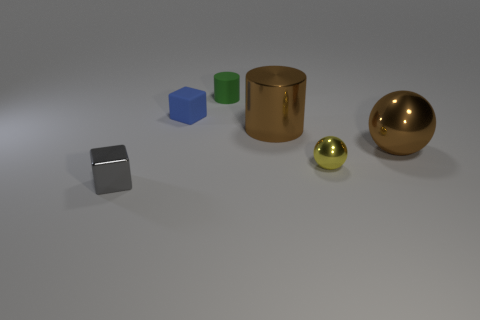Are there any patterns or textures visible on the surfaces in the image? The objects in the image display smooth surfaces without any distinct patterns or textures. The base surface has a slight graininess which is noticeable upon closer inspection. 